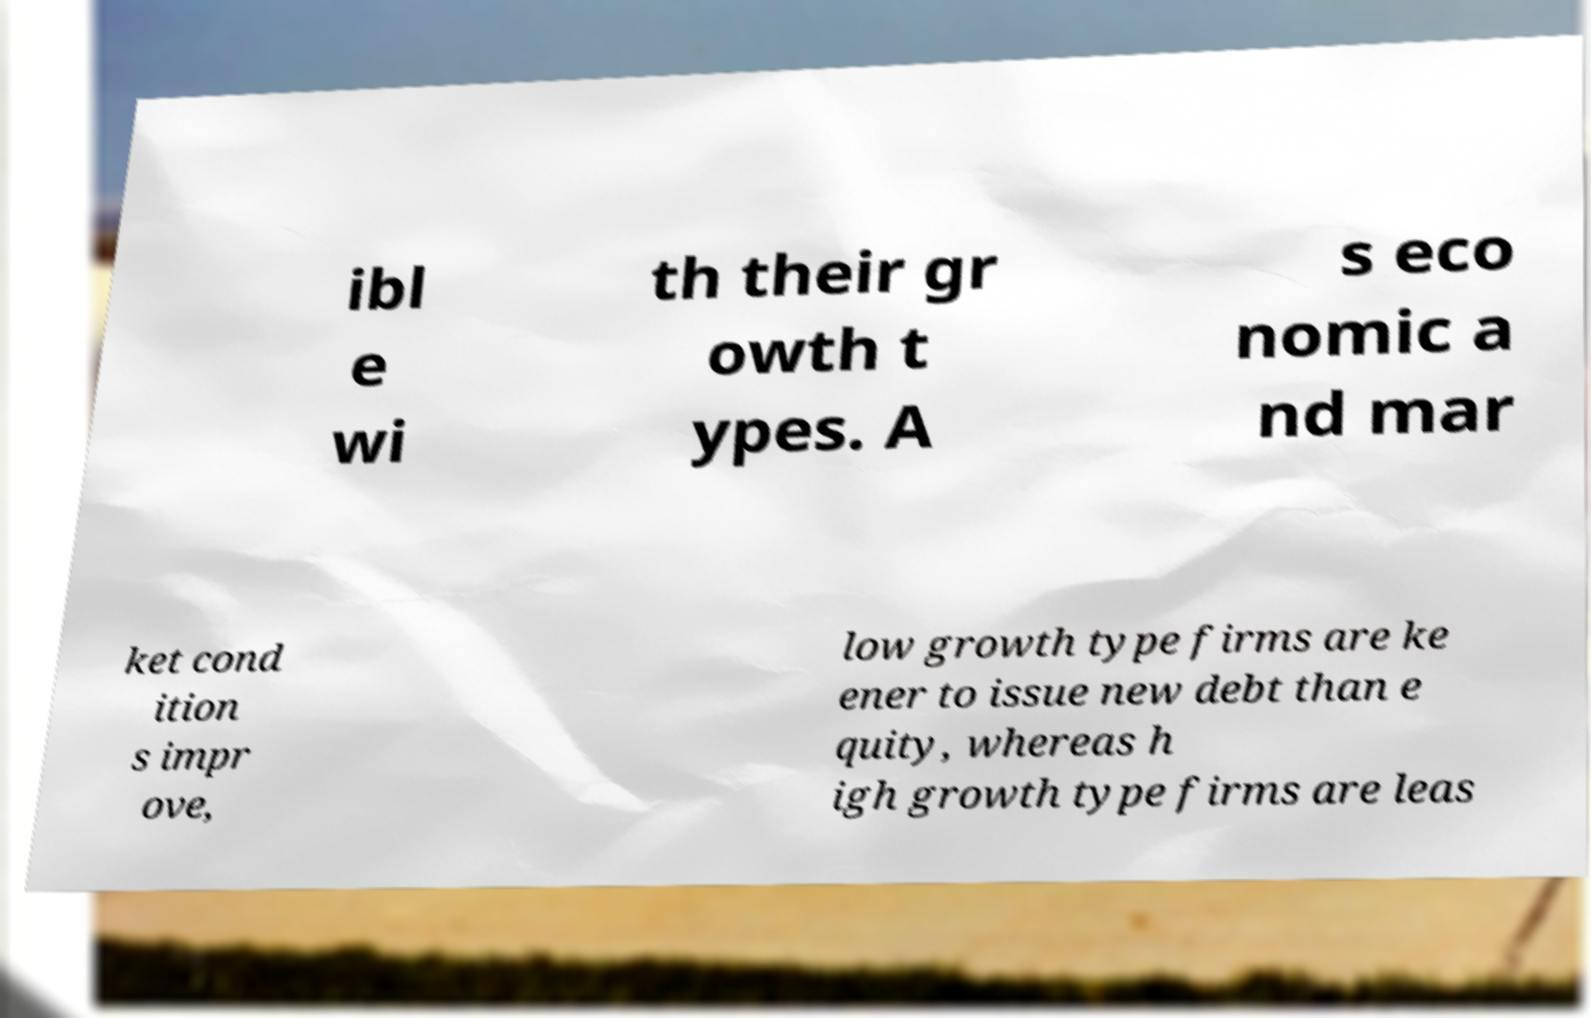I need the written content from this picture converted into text. Can you do that? ibl e wi th their gr owth t ypes. A s eco nomic a nd mar ket cond ition s impr ove, low growth type firms are ke ener to issue new debt than e quity, whereas h igh growth type firms are leas 